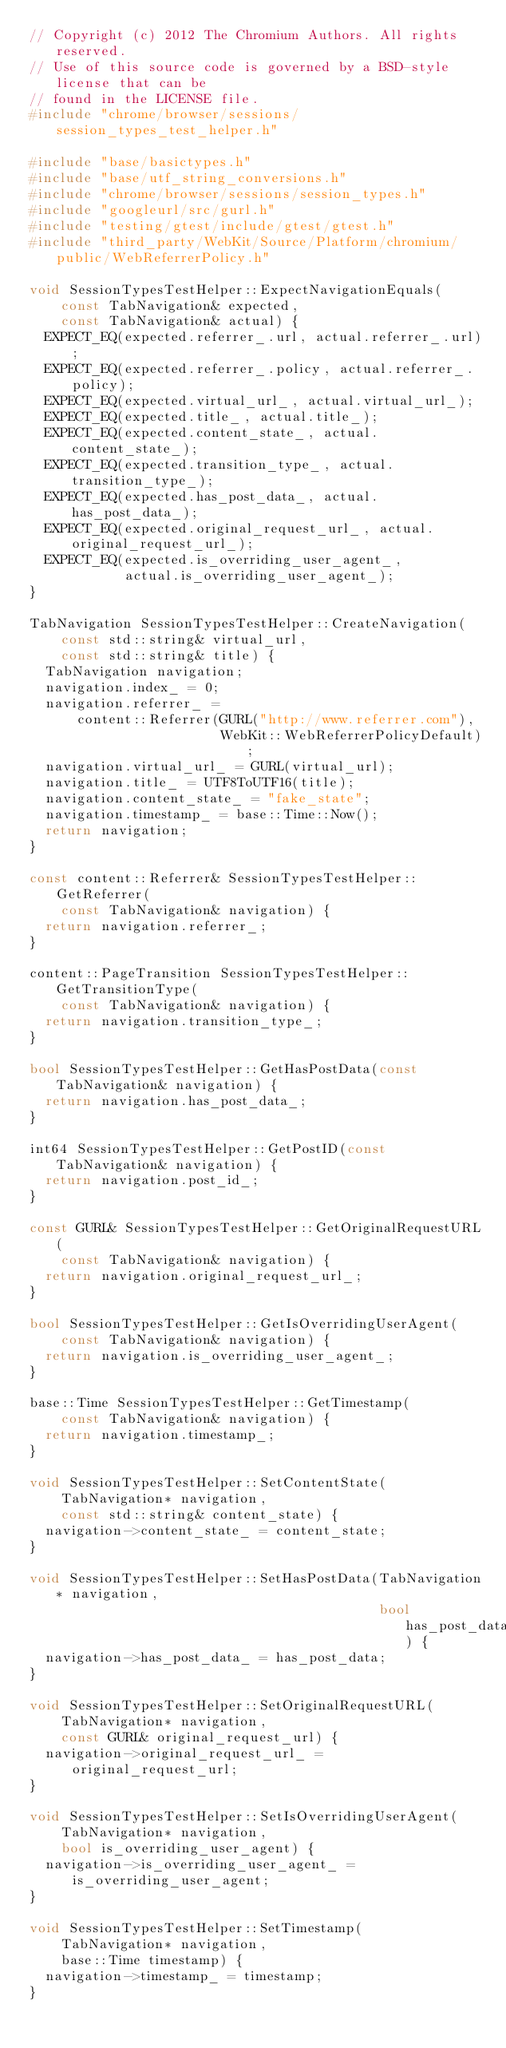<code> <loc_0><loc_0><loc_500><loc_500><_C++_>// Copyright (c) 2012 The Chromium Authors. All rights reserved.
// Use of this source code is governed by a BSD-style license that can be
// found in the LICENSE file.
#include "chrome/browser/sessions/session_types_test_helper.h"

#include "base/basictypes.h"
#include "base/utf_string_conversions.h"
#include "chrome/browser/sessions/session_types.h"
#include "googleurl/src/gurl.h"
#include "testing/gtest/include/gtest/gtest.h"
#include "third_party/WebKit/Source/Platform/chromium/public/WebReferrerPolicy.h"

void SessionTypesTestHelper::ExpectNavigationEquals(
    const TabNavigation& expected,
    const TabNavigation& actual) {
  EXPECT_EQ(expected.referrer_.url, actual.referrer_.url);
  EXPECT_EQ(expected.referrer_.policy, actual.referrer_.policy);
  EXPECT_EQ(expected.virtual_url_, actual.virtual_url_);
  EXPECT_EQ(expected.title_, actual.title_);
  EXPECT_EQ(expected.content_state_, actual.content_state_);
  EXPECT_EQ(expected.transition_type_, actual.transition_type_);
  EXPECT_EQ(expected.has_post_data_, actual.has_post_data_);
  EXPECT_EQ(expected.original_request_url_, actual.original_request_url_);
  EXPECT_EQ(expected.is_overriding_user_agent_,
            actual.is_overriding_user_agent_);
}

TabNavigation SessionTypesTestHelper::CreateNavigation(
    const std::string& virtual_url,
    const std::string& title) {
  TabNavigation navigation;
  navigation.index_ = 0;
  navigation.referrer_ =
      content::Referrer(GURL("http://www.referrer.com"),
                        WebKit::WebReferrerPolicyDefault);
  navigation.virtual_url_ = GURL(virtual_url);
  navigation.title_ = UTF8ToUTF16(title);
  navigation.content_state_ = "fake_state";
  navigation.timestamp_ = base::Time::Now();
  return navigation;
}

const content::Referrer& SessionTypesTestHelper::GetReferrer(
    const TabNavigation& navigation) {
  return navigation.referrer_;
}

content::PageTransition SessionTypesTestHelper::GetTransitionType(
    const TabNavigation& navigation) {
  return navigation.transition_type_;
}

bool SessionTypesTestHelper::GetHasPostData(const TabNavigation& navigation) {
  return navigation.has_post_data_;
}

int64 SessionTypesTestHelper::GetPostID(const TabNavigation& navigation) {
  return navigation.post_id_;
}

const GURL& SessionTypesTestHelper::GetOriginalRequestURL(
    const TabNavigation& navigation) {
  return navigation.original_request_url_;
}

bool SessionTypesTestHelper::GetIsOverridingUserAgent(
    const TabNavigation& navigation) {
  return navigation.is_overriding_user_agent_;
}

base::Time SessionTypesTestHelper::GetTimestamp(
    const TabNavigation& navigation) {
  return navigation.timestamp_;
}

void SessionTypesTestHelper::SetContentState(
    TabNavigation* navigation,
    const std::string& content_state) {
  navigation->content_state_ = content_state;
}

void SessionTypesTestHelper::SetHasPostData(TabNavigation* navigation,
                                            bool has_post_data) {
  navigation->has_post_data_ = has_post_data;
}

void SessionTypesTestHelper::SetOriginalRequestURL(
    TabNavigation* navigation,
    const GURL& original_request_url) {
  navigation->original_request_url_ = original_request_url;
}

void SessionTypesTestHelper::SetIsOverridingUserAgent(
    TabNavigation* navigation,
    bool is_overriding_user_agent) {
  navigation->is_overriding_user_agent_ = is_overriding_user_agent;
}

void SessionTypesTestHelper::SetTimestamp(
    TabNavigation* navigation,
    base::Time timestamp) {
  navigation->timestamp_ = timestamp;
}
</code> 